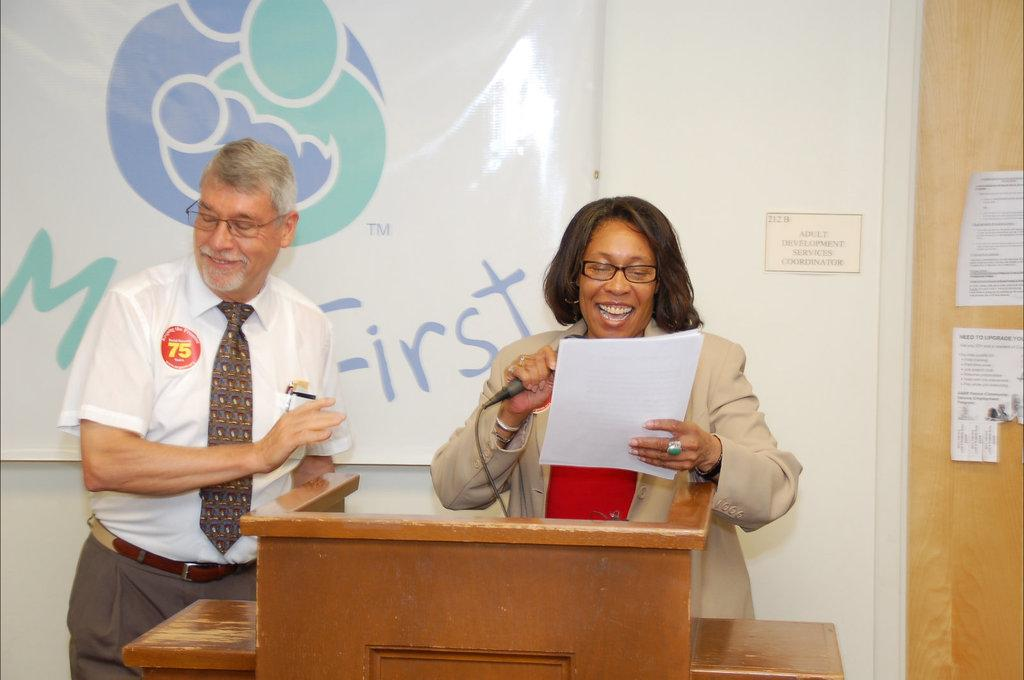How many people are in the image? There are two people in the image, a man and a woman. What are the man and woman doing in the image? Both the man and woman are standing at a podium. What is the woman doing specifically? The woman is speaking with the help of a microphone and holding a paper in her hand. What is visible behind the man and woman? There is a board visible behind them. What type of dogs are sitting at the woman's feet in the image? There are no dogs present in the image. What color is the skirt the woman is wearing in the image? The woman is not wearing a skirt in the image; she is wearing a dress or pants. 